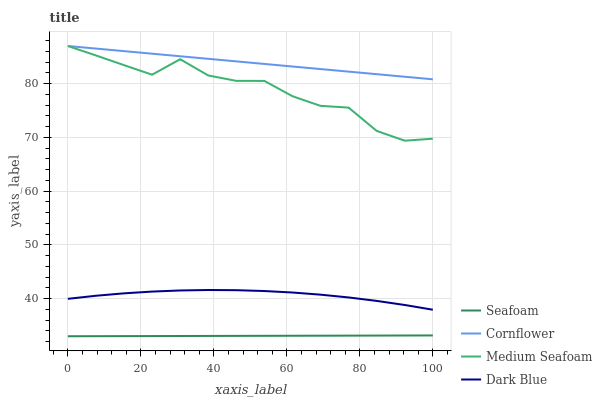Does Seafoam have the minimum area under the curve?
Answer yes or no. Yes. Does Cornflower have the maximum area under the curve?
Answer yes or no. Yes. Does Dark Blue have the minimum area under the curve?
Answer yes or no. No. Does Dark Blue have the maximum area under the curve?
Answer yes or no. No. Is Cornflower the smoothest?
Answer yes or no. Yes. Is Medium Seafoam the roughest?
Answer yes or no. Yes. Is Dark Blue the smoothest?
Answer yes or no. No. Is Dark Blue the roughest?
Answer yes or no. No. Does Seafoam have the lowest value?
Answer yes or no. Yes. Does Dark Blue have the lowest value?
Answer yes or no. No. Does Medium Seafoam have the highest value?
Answer yes or no. Yes. Does Dark Blue have the highest value?
Answer yes or no. No. Is Dark Blue less than Medium Seafoam?
Answer yes or no. Yes. Is Dark Blue greater than Seafoam?
Answer yes or no. Yes. Does Medium Seafoam intersect Cornflower?
Answer yes or no. Yes. Is Medium Seafoam less than Cornflower?
Answer yes or no. No. Is Medium Seafoam greater than Cornflower?
Answer yes or no. No. Does Dark Blue intersect Medium Seafoam?
Answer yes or no. No. 